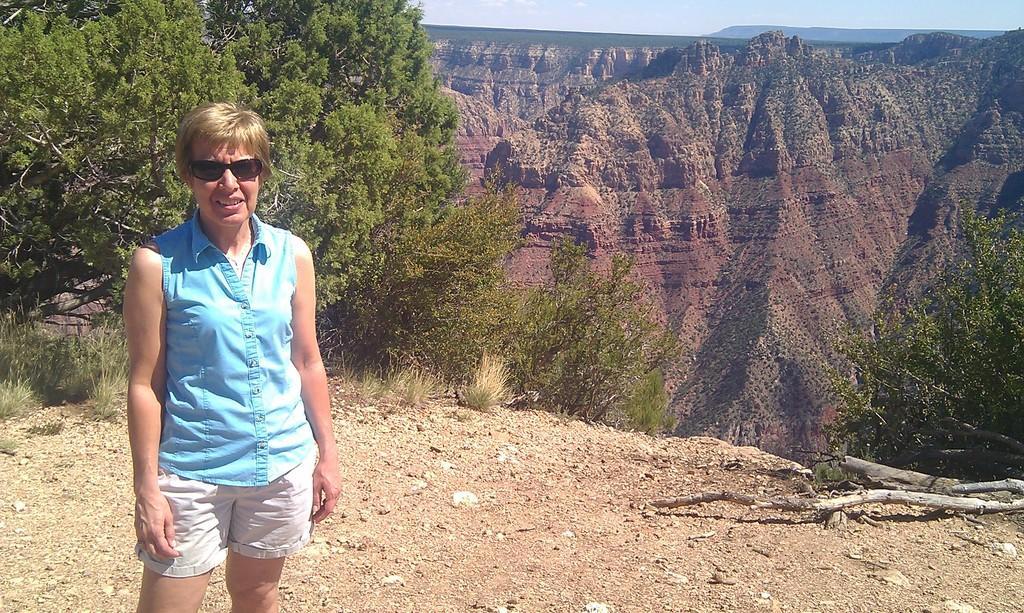Describe this image in one or two sentences. On the left side of the image we can see a person is standing and she is in a different costume. And we can see she is wearing glasses. In the background, we can see the sky, trees, hills and a few other objects. 